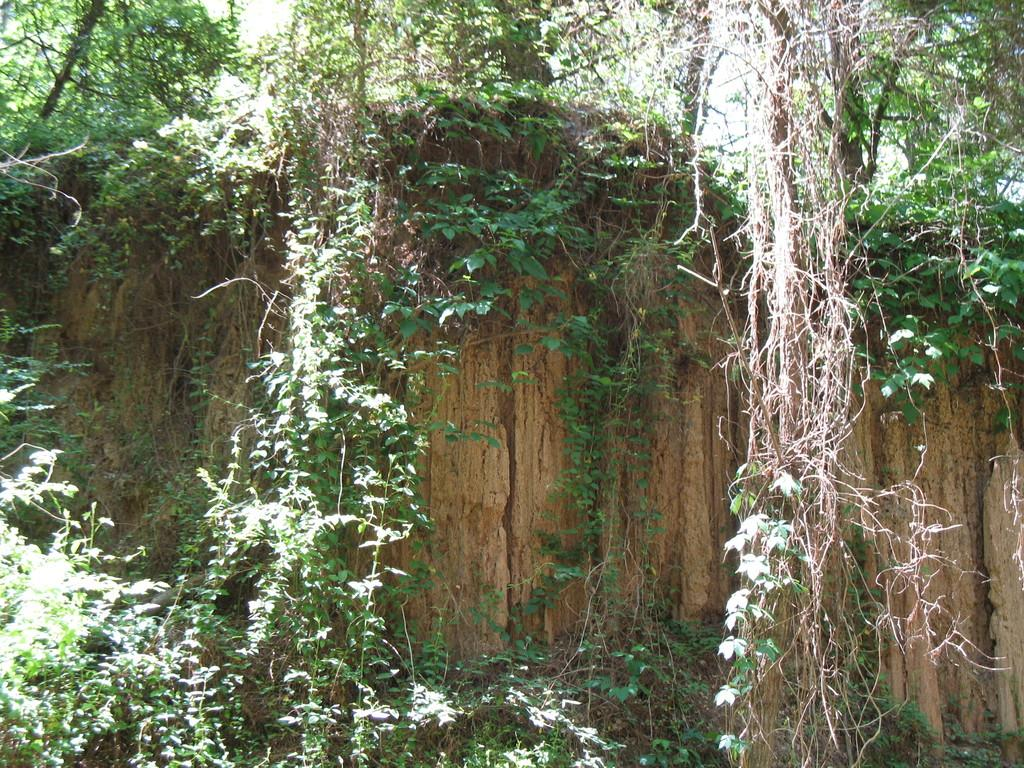What type of vegetation can be seen in the image? There are plants and trees in the image. Can you describe the trees in the image? The trees in the image are visible alongside the plants. How many goldfish can be seen swimming in the image? There are no goldfish present in the image; it features plants and trees. What type of houses are visible in the image? There are no houses present in the image; it features plants and trees. 